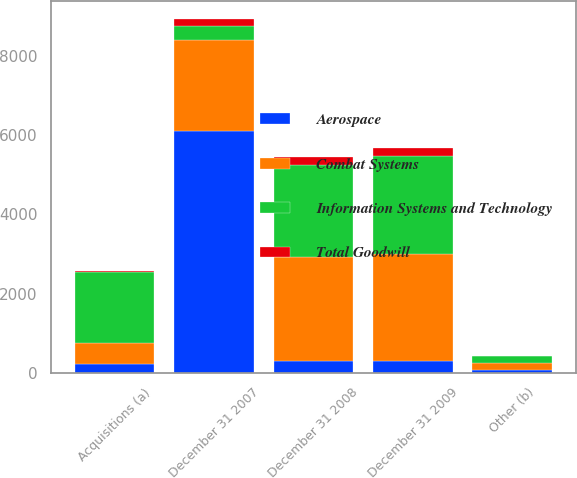Convert chart to OTSL. <chart><loc_0><loc_0><loc_500><loc_500><stacked_bar_chart><ecel><fcel>December 31 2007<fcel>Acquisitions (a)<fcel>Other (b)<fcel>December 31 2008<fcel>December 31 2009<nl><fcel>Information Systems and Technology<fcel>355<fcel>1795<fcel>166<fcel>2316<fcel>2480<nl><fcel>Combat Systems<fcel>2308<fcel>529<fcel>199<fcel>2638<fcel>2710<nl><fcel>Total Goodwill<fcel>185<fcel>6<fcel>1<fcel>192<fcel>198<nl><fcel>Aerospace<fcel>6094<fcel>234<fcel>61<fcel>294.5<fcel>294.5<nl></chart> 